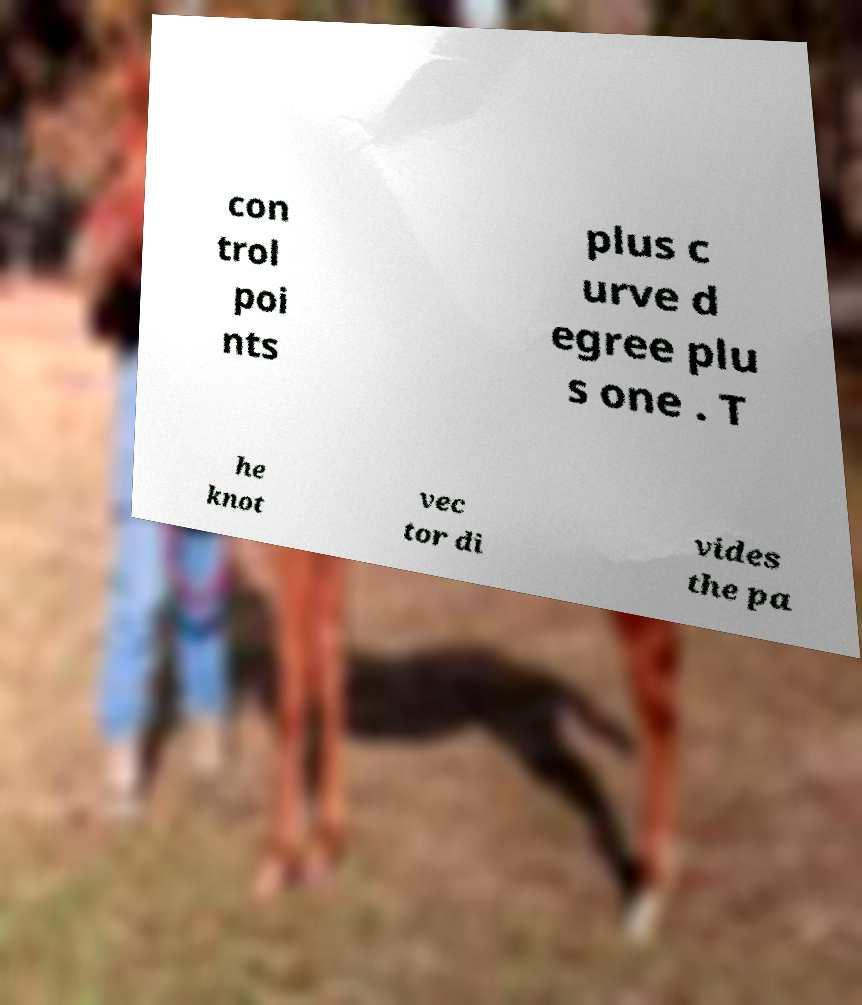What messages or text are displayed in this image? I need them in a readable, typed format. con trol poi nts plus c urve d egree plu s one . T he knot vec tor di vides the pa 